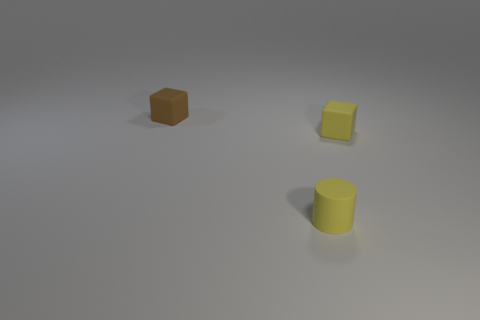Add 1 small yellow matte cubes. How many objects exist? 4 Subtract all cylinders. How many objects are left? 2 Subtract 1 cylinders. How many cylinders are left? 0 Subtract all rubber objects. Subtract all big yellow cubes. How many objects are left? 0 Add 1 tiny yellow things. How many tiny yellow things are left? 3 Add 2 small rubber cubes. How many small rubber cubes exist? 4 Subtract 0 red blocks. How many objects are left? 3 Subtract all gray blocks. Subtract all blue cylinders. How many blocks are left? 2 